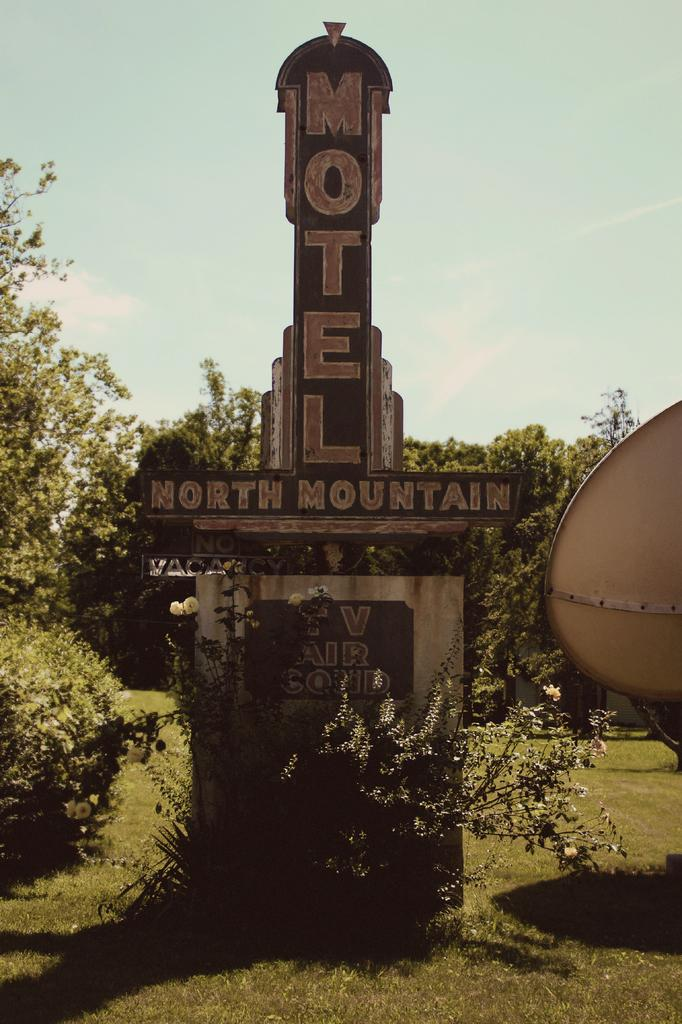What type of structure is present in the image? There is a structure with text in the image. What type of vegetation can be seen in the image? There are trees in the image. What type of ground cover is visible in the image? There is grass visible in the image. What is visible in the background of the image? The sky is visible in the image. What type of skin condition can be seen on the trees in the image? There is no mention of any skin condition on the trees in the image. The trees appear to be healthy and normal. 